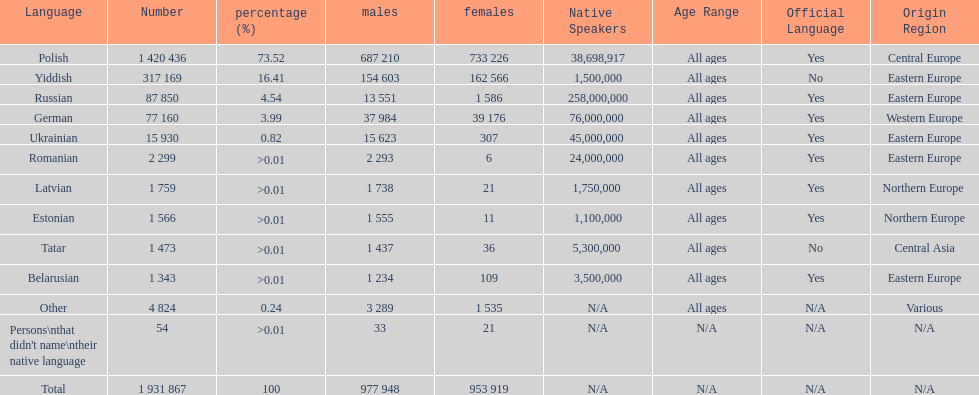Which language had the most number of people speaking it. Polish. 